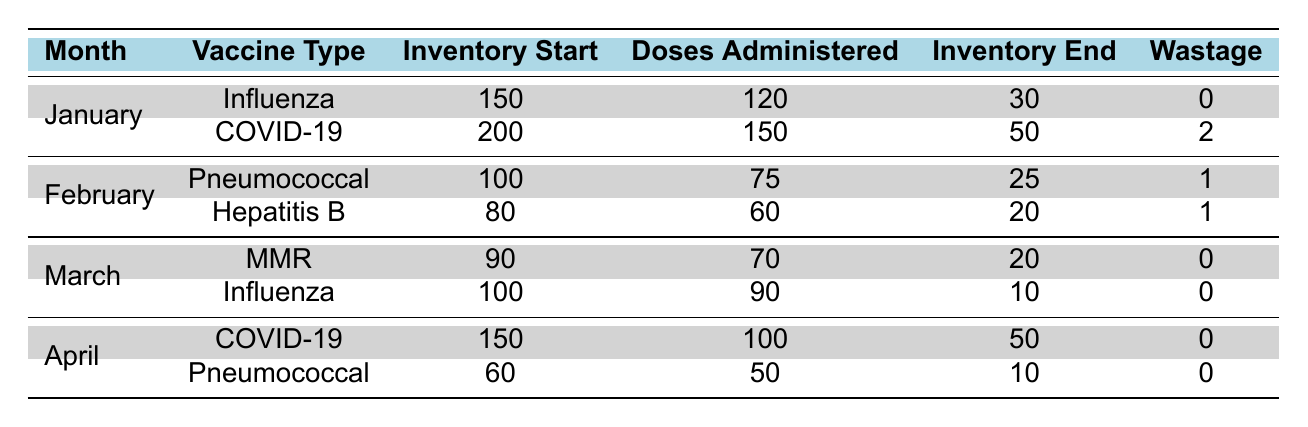What was the total number of doses administered for COVID-19 in January and April? In January, 150 doses of the COVID-19 vaccine were administered, and in April, 100 doses were administered. Adding these together gives 150 + 100 = 250 doses in total.
Answer: 250 Which month had the highest wastage of vaccines? The table shows that January had 2 units of wastage for COVID-19, while the other months only had 0 or 1 unit of wastage. Therefore, January had the highest wastage of vaccines.
Answer: January What is the inventory end for Hepatitis B in February? The table lists the inventory end for Hepatitis B in February as 20. This is directly retrieved from the data presented.
Answer: 20 Calculate the average inventory start for all vaccines listed in the table. The inventory start values for all vaccines are 150, 200, 100, 80, 90, 100, 150, and 60. Adding these values gives 150 + 200 + 100 + 80 + 90 + 100 + 150 + 60 = 930. There are 8 vaccines, so to find the average, we divide 930 by 8, resulting in 116.25.
Answer: 116.25 Did any vaccine have zero doses administered in any month? By reviewing the doses administered column for each vaccine in each month, all vaccines had doses administered greater than zero for the months listed. Therefore, no vaccine had zero doses administered in any month.
Answer: No What was the total inventory start for Influenza vaccinations across all months? Influenza vaccinations had an inventory start of 150 in January and 100 in March. Adding these values gives 150 + 100 = 250 for the total inventory start for Influenza vaccinations across both months.
Answer: 250 Which vaccine had the lowest remaining inventory at the end of March? At the end of March, the MMR vaccine had an inventory of 20, and the Influenza vaccine had an inventory of 10. Since 10 is lower than 20, the Influenza vaccine had the lowest remaining inventory at the end of March.
Answer: Influenza How many doses were administered for Pneumococcal vaccine in total across February and April? The table shows that 75 doses of the Pneumococcal vaccine were administered in February and 50 doses were administered in April. Adding these gives 75 + 50 = 125 doses in total.
Answer: 125 Is it true that all vaccines had a wastage of zero in the month of April? The table shows that both COVID-19 and Pneumococcal vaccines had a wastage of 0 in April. Since both vaccines registered zero wastage, it is true that all vaccines had a wastage of zero in April.
Answer: Yes 